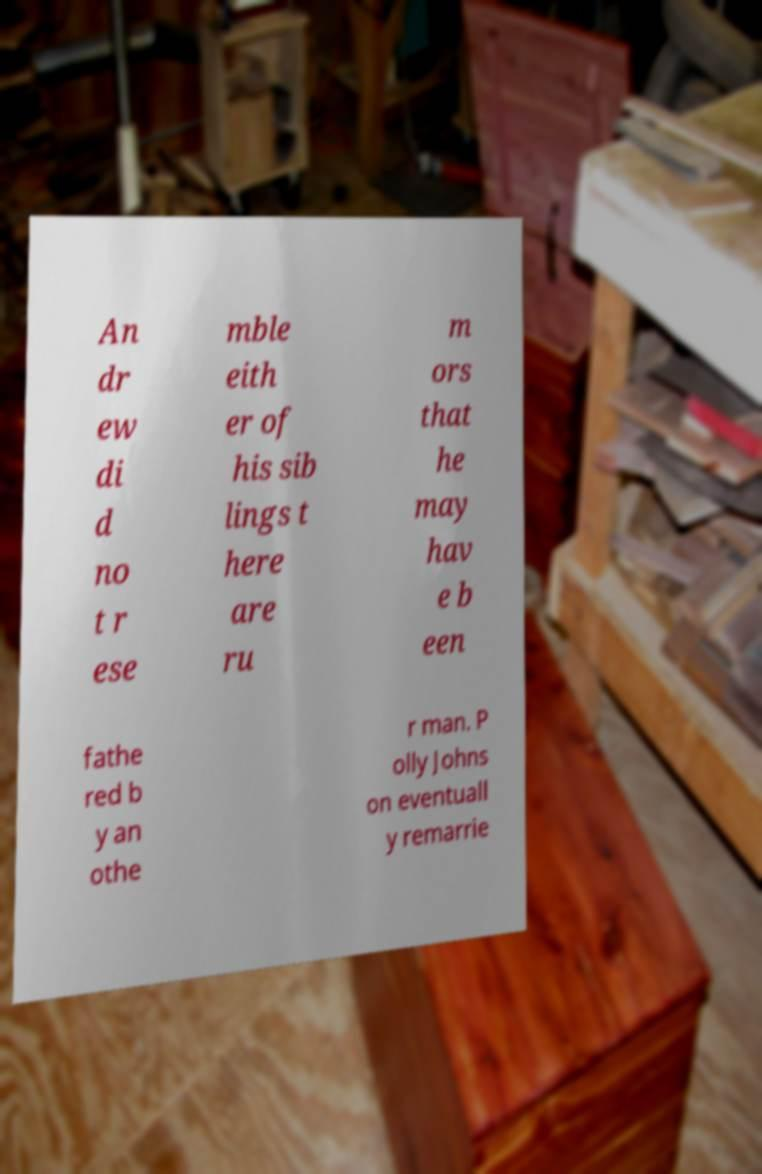For documentation purposes, I need the text within this image transcribed. Could you provide that? An dr ew di d no t r ese mble eith er of his sib lings t here are ru m ors that he may hav e b een fathe red b y an othe r man. P olly Johns on eventuall y remarrie 